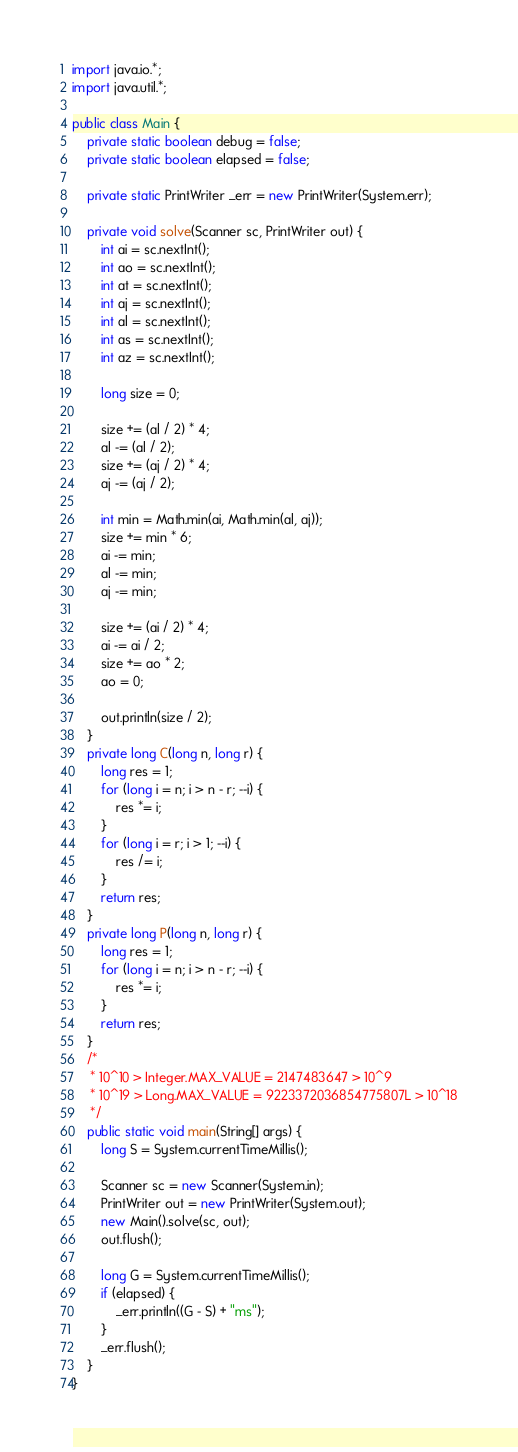Convert code to text. <code><loc_0><loc_0><loc_500><loc_500><_Java_>import java.io.*;
import java.util.*;

public class Main {
    private static boolean debug = false;
    private static boolean elapsed = false;

    private static PrintWriter _err = new PrintWriter(System.err);

    private void solve(Scanner sc, PrintWriter out) {
        int ai = sc.nextInt();
        int ao = sc.nextInt();
        int at = sc.nextInt();
        int aj = sc.nextInt();
        int al = sc.nextInt();
        int as = sc.nextInt();
        int az = sc.nextInt();

        long size = 0;

        size += (al / 2) * 4;
        al -= (al / 2);
        size += (aj / 2) * 4;
        aj -= (aj / 2);

        int min = Math.min(ai, Math.min(al, aj));
        size += min * 6;
        ai -= min;
        al -= min;
        aj -= min;

        size += (ai / 2) * 4;
        ai -= ai / 2;
        size += ao * 2;
        ao = 0;

        out.println(size / 2);
    }
    private long C(long n, long r) {
        long res = 1;
        for (long i = n; i > n - r; --i) {
            res *= i;
        }
        for (long i = r; i > 1; --i) {
            res /= i;
        }
        return res;
    }
    private long P(long n, long r) {
        long res = 1;
        for (long i = n; i > n - r; --i) {
            res *= i;
        }
        return res;
    }
    /*
     * 10^10 > Integer.MAX_VALUE = 2147483647 > 10^9
     * 10^19 > Long.MAX_VALUE = 9223372036854775807L > 10^18
     */
    public static void main(String[] args) {
        long S = System.currentTimeMillis();

        Scanner sc = new Scanner(System.in);
        PrintWriter out = new PrintWriter(System.out);
        new Main().solve(sc, out);
        out.flush();

        long G = System.currentTimeMillis();
        if (elapsed) {
            _err.println((G - S) + "ms");
        }
        _err.flush();
    }
}</code> 